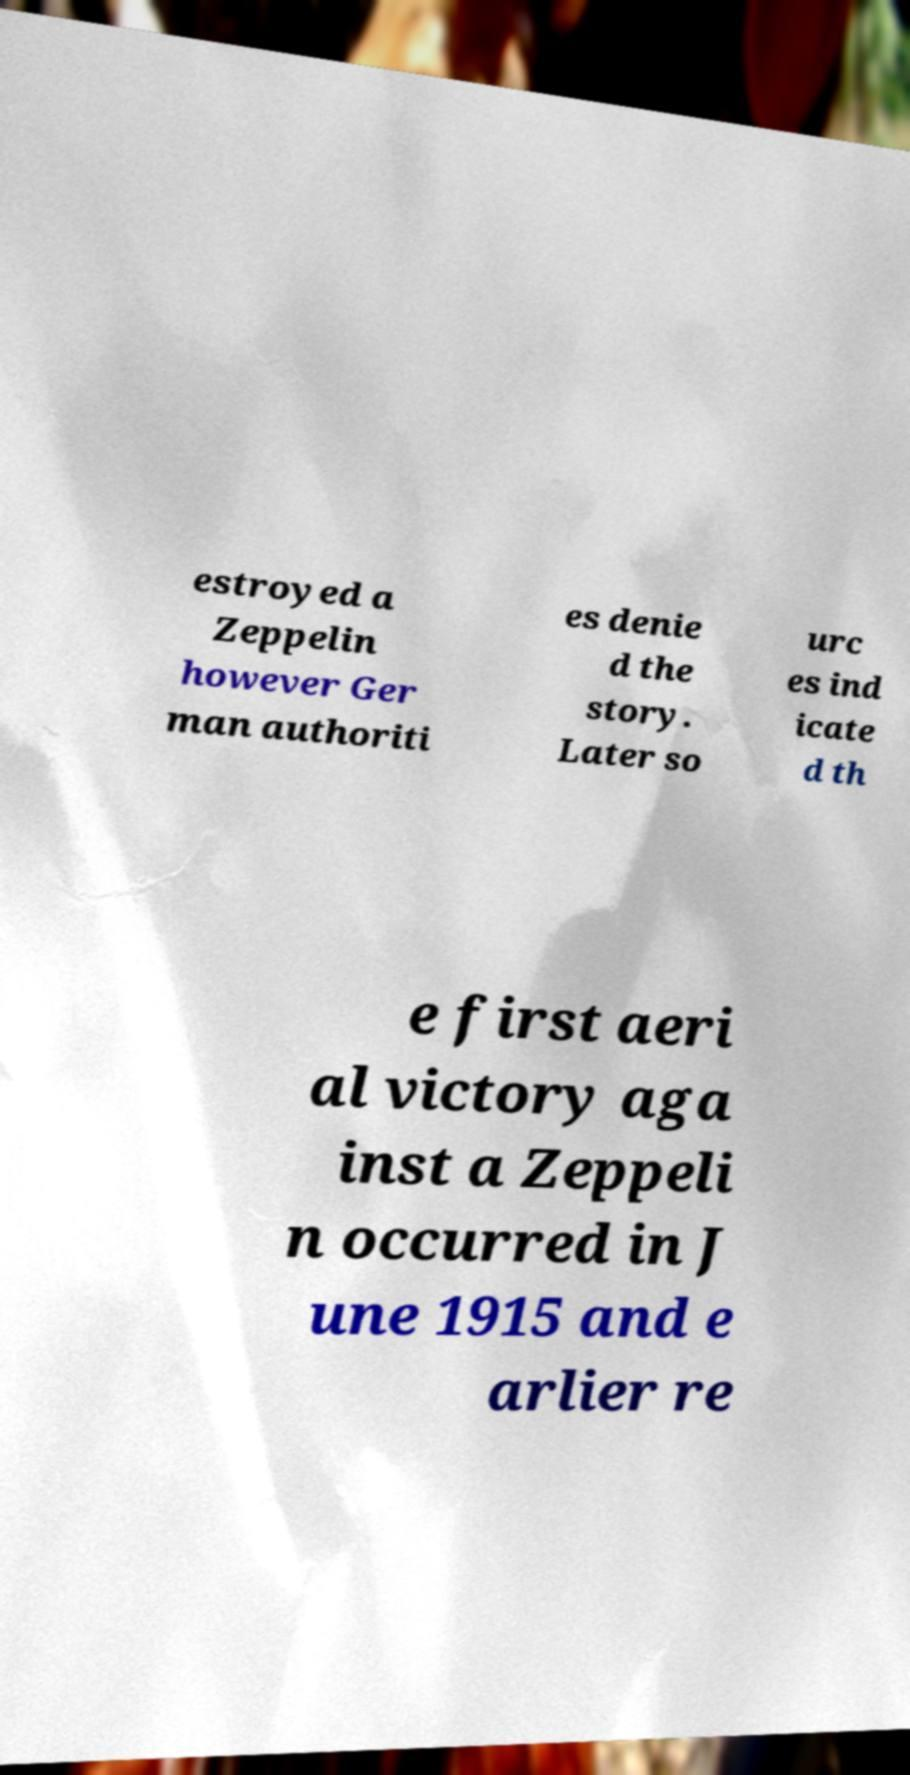There's text embedded in this image that I need extracted. Can you transcribe it verbatim? estroyed a Zeppelin however Ger man authoriti es denie d the story. Later so urc es ind icate d th e first aeri al victory aga inst a Zeppeli n occurred in J une 1915 and e arlier re 